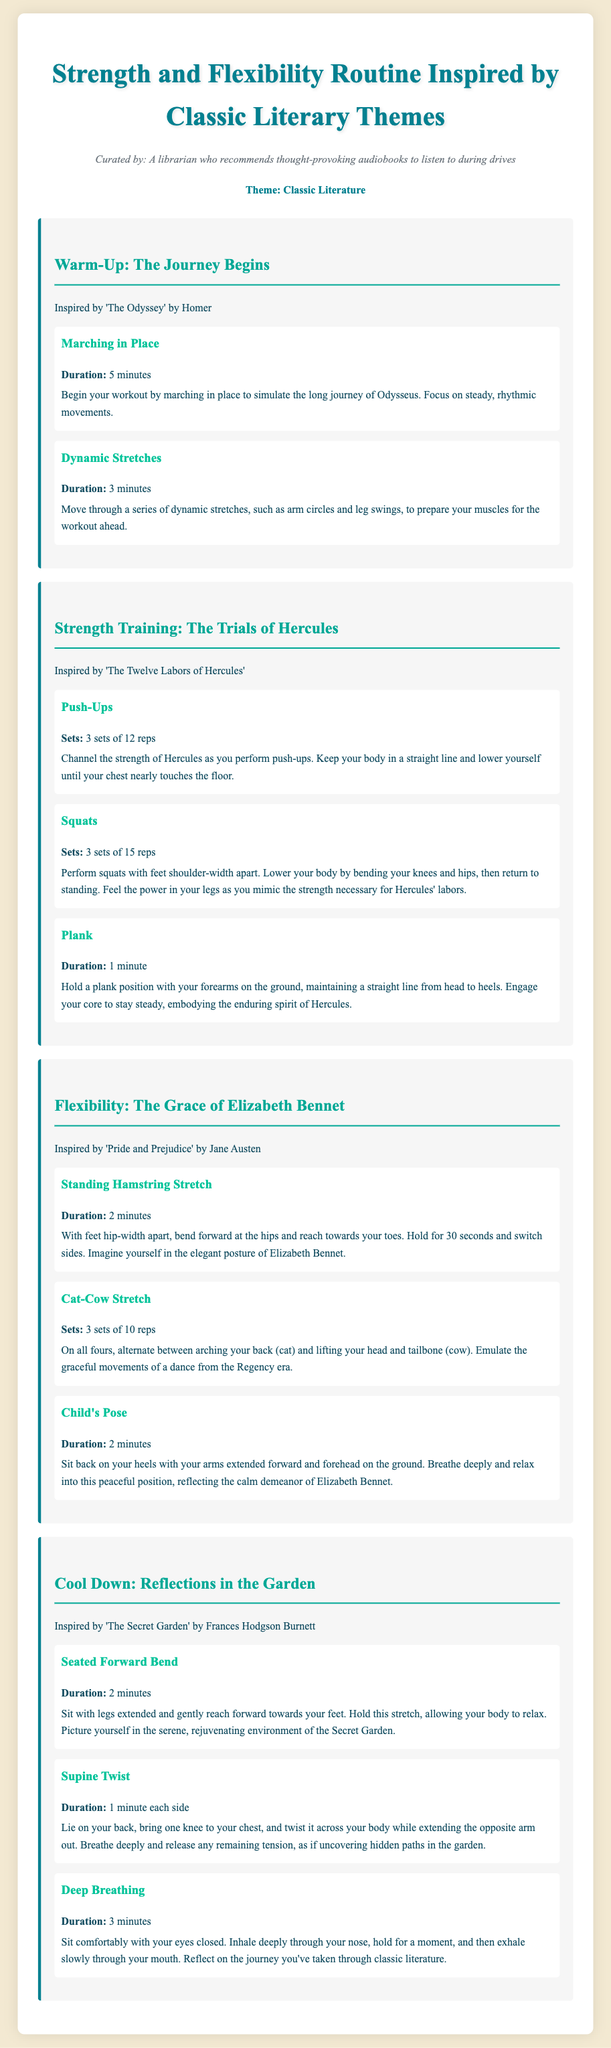What is the theme of the workout plan? The theme is Classic Literature, as stated at the top of the document.
Answer: Classic Literature Which exercise is inspired by 'The Odyssey'? 'Marching in Place' and 'Dynamic Stretches' are part of the warm-up section inspired by The Odyssey.
Answer: Marching in Place How many sets of push-ups are recommended? The document specifies that there are 3 sets of 12 reps for push-ups.
Answer: 3 sets of 12 reps What literary character is associated with the flexibility section? The flexibility section is inspired by Elizabeth Bennet from 'Pride and Prejudice'.
Answer: Elizabeth Bennet What is the duration of the deep breathing exercise? The duration for the deep breathing exercise is stated as 3 minutes.
Answer: 3 minutes In which section should you perform the Supine Twist? The Supine Twist is part of the cool-down section, indicating it's performed at the end of the workout.
Answer: Cool Down What stretch simulates the elegant posture of Elizabeth Bennet? The document indicates that the Standing Hamstring Stretch simulates Elizabeth Bennet's elegant posture.
Answer: Standing Hamstring Stretch How long should the plank be held? The document specifies the duration for holding the plank is 1 minute.
Answer: 1 minute 